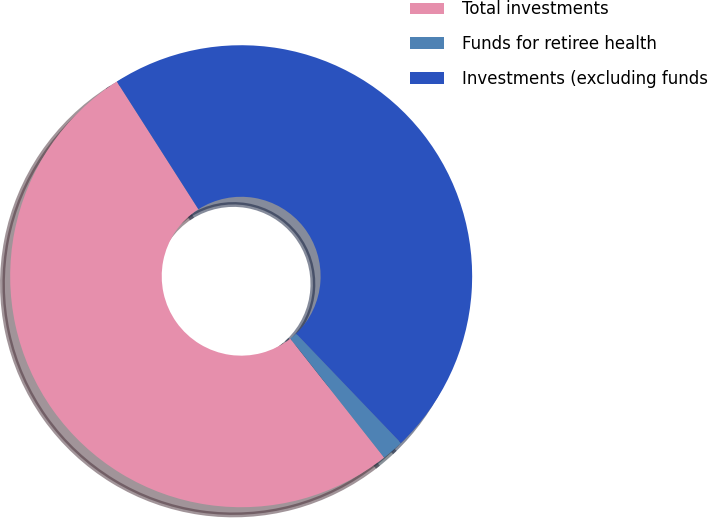Convert chart to OTSL. <chart><loc_0><loc_0><loc_500><loc_500><pie_chart><fcel>Total investments<fcel>Funds for retiree health<fcel>Investments (excluding funds<nl><fcel>51.58%<fcel>1.53%<fcel>46.89%<nl></chart> 